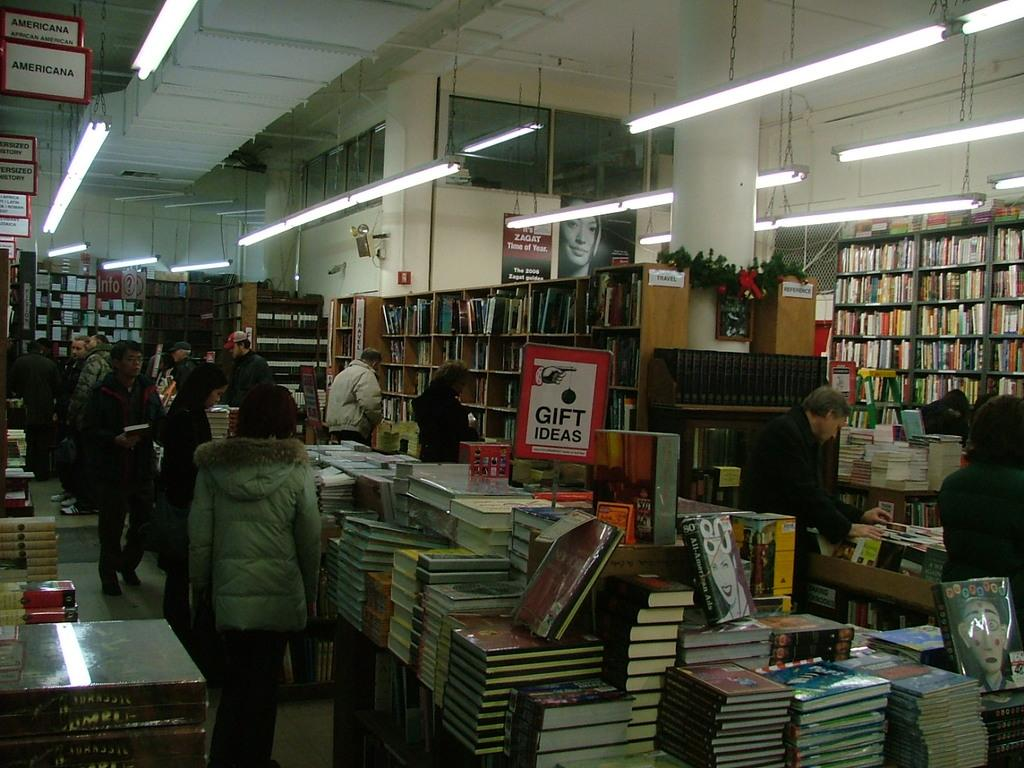<image>
Share a concise interpretation of the image provided. A sign in a library has the words gift ideas. 